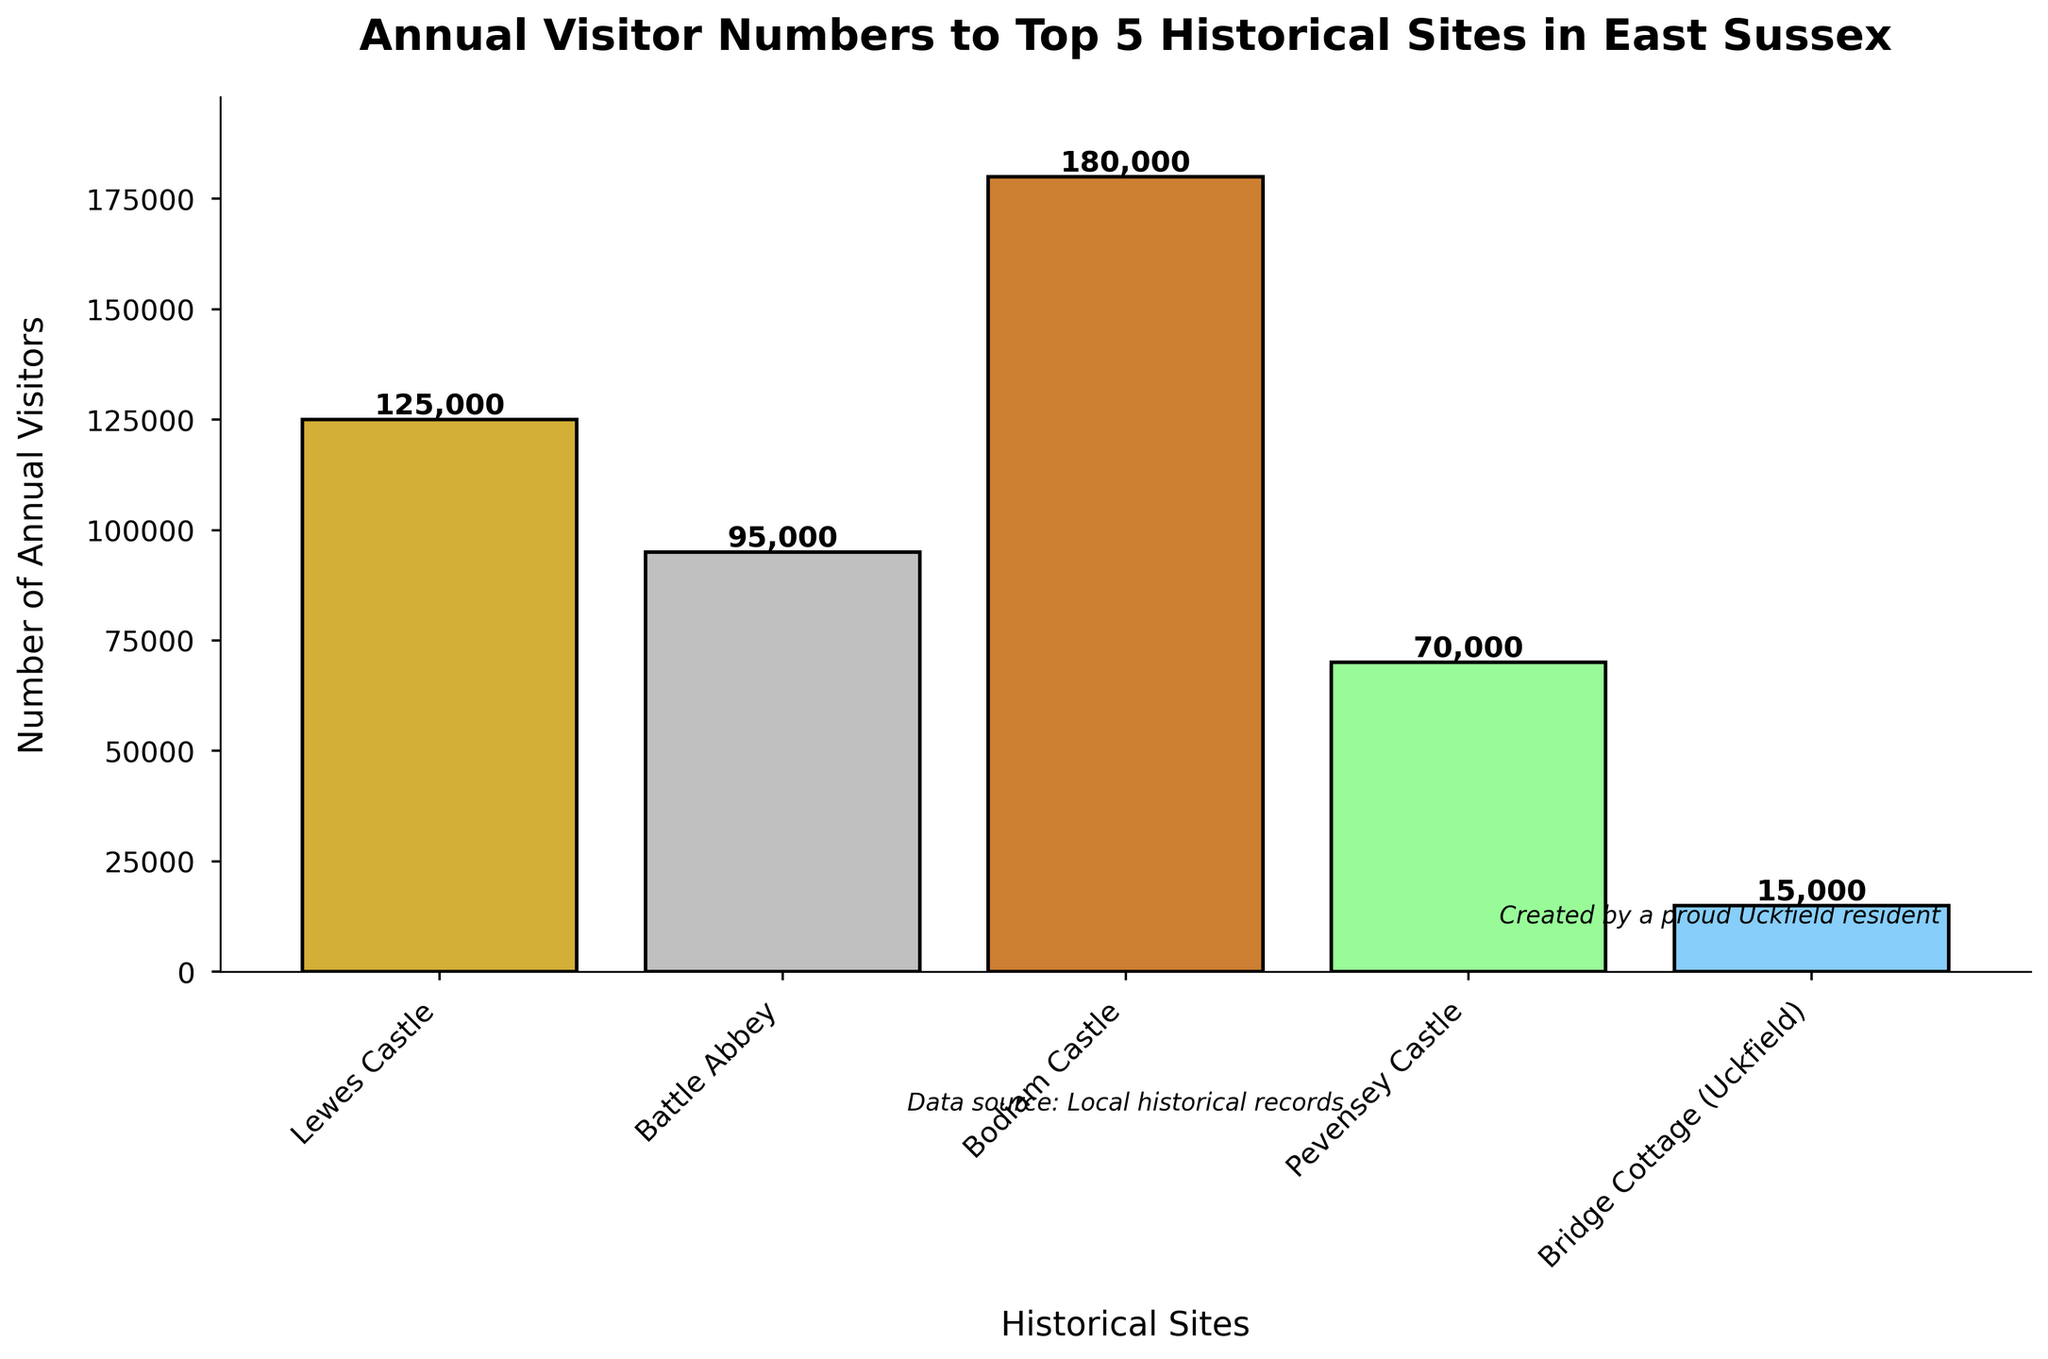Which historical site in East Sussex has the highest annual visitor numbers? The site with the highest bar represents the most visitors. Bodiam Castle has the tallest bar.
Answer: Bodiam Castle How many more visitors does Lewes Castle have compared to Pevensey Castle? Lewes Castle has 125,000 visitors, and Pevensey Castle has 70,000 visitors. The difference is 125,000 - 70,000 = 55,000.
Answer: 55,000 Which site has the fewest visitors, and what is their visitor count? The shortest bar represents the fewest visitors. Bridge Cottage has the shortest bar, with 15,000 visitors.
Answer: Bridge Cottage, 15,000 What is the average number of visitors across all sites? Add the visitor numbers for all sites and divide by the number of sites: (125,000 + 95,000 + 180,000 + 70,000 + 15,000) / 5 = 485,000 / 5 = 97,000.
Answer: 97,000 How many total visitors do the top three sites (Bodiam Castle, Lewes Castle, and Battle Abbey) have combined? Sum the visitors of the top three sites: Bodiam Castle (180,000) + Lewes Castle (125,000) + Battle Abbey (95,000) = 400,000.
Answer: 400,000 What is the visitor count difference between the site with the second most visitors and the site with the second fewest visitors? Battle Abbey has the second most visitors (95,000) and Pevensey Castle has the second fewest visitors (70,000). The difference is 95,000 - 70,000 = 25,000.
Answer: 25,000 Which historical site uses a green bar color to represent its visitor count? The legend shows the color coding of bars. The green bar color corresponds to Pevensey Castle.
Answer: Pevensey Castle What percentage of the total visitors does Bridge Cottage receive? First, find the total number of visitors: 485,000. Then, calculate the percentage of visitors for Bridge Cottage: (15,000 / 485,000) * 100 ≈ 3.09%.
Answer: ≈ 3.09% How much taller is the bar representing Bodiam Castle compared to the bar representing Bridge Cottage? Bodiam Castle's bar height is 180,000; Bridge Cottage's is 15,000. The difference in height is 180,000 - 15,000 = 165,000.
Answer: 165,000 Which historical sites have a visitor count within 90,000 and 130,000? Identify the bars that fall within this range by their height. Lewes Castle has 125,000 visitors and Battle Abbey has 95,000 visitors.
Answer: Lewes Castle, Battle Abbey 